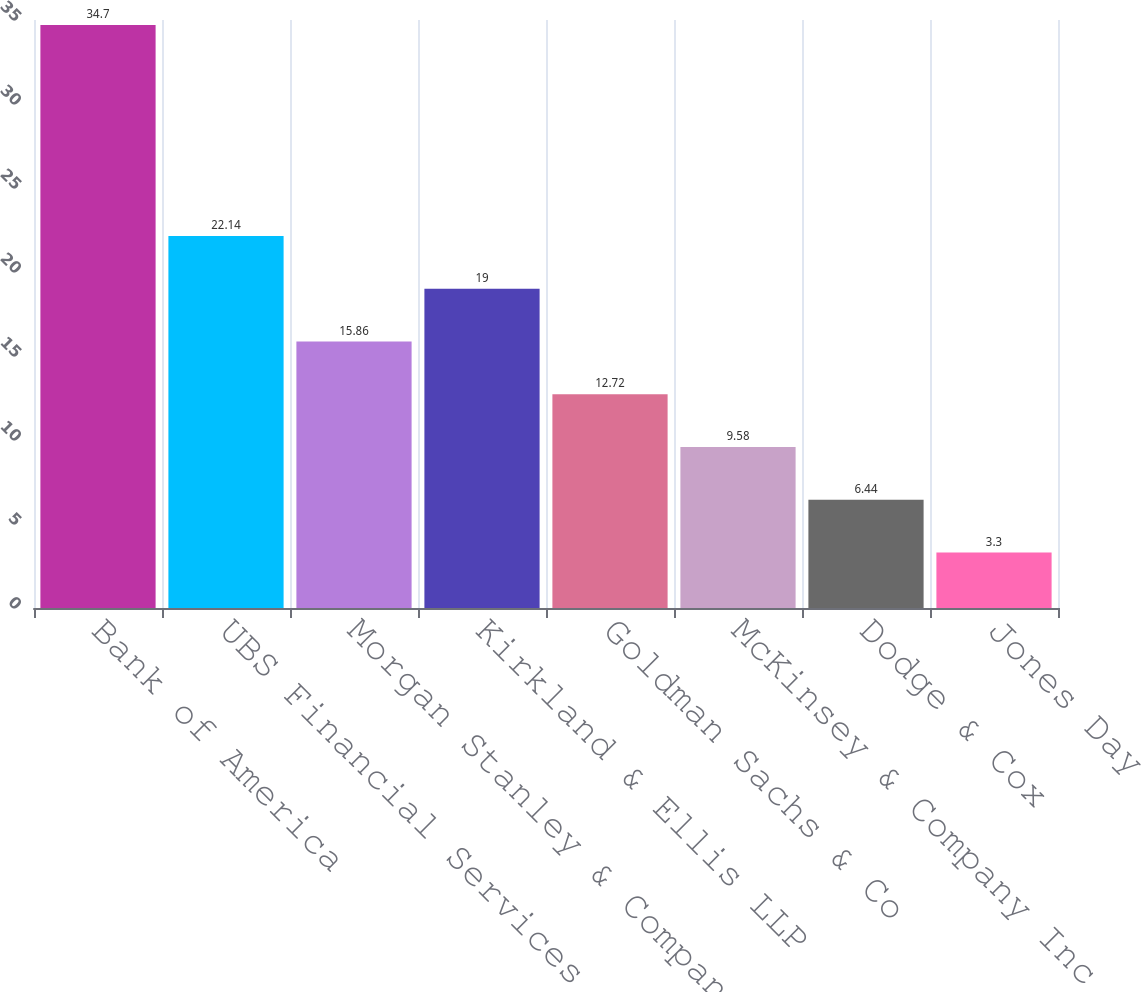Convert chart. <chart><loc_0><loc_0><loc_500><loc_500><bar_chart><fcel>Bank of America<fcel>UBS Financial Services<fcel>Morgan Stanley & Company Inc<fcel>Kirkland & Ellis LLP<fcel>Goldman Sachs & Co<fcel>McKinsey & Company Inc<fcel>Dodge & Cox<fcel>Jones Day<nl><fcel>34.7<fcel>22.14<fcel>15.86<fcel>19<fcel>12.72<fcel>9.58<fcel>6.44<fcel>3.3<nl></chart> 